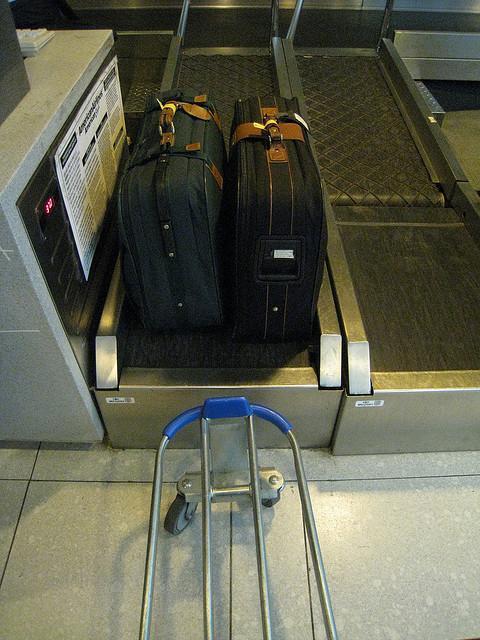How many suitcases are being weighed?
Give a very brief answer. 2. How many suitcases can you see?
Give a very brief answer. 2. How many people are on the motorcycle?
Give a very brief answer. 0. 